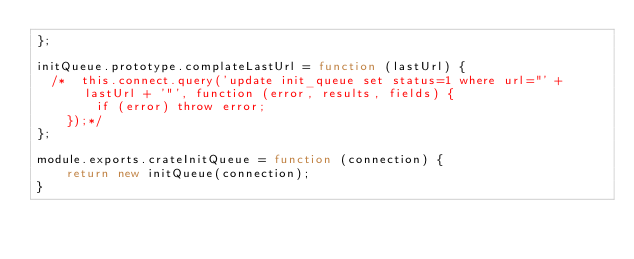Convert code to text. <code><loc_0><loc_0><loc_500><loc_500><_JavaScript_>};

initQueue.prototype.complateLastUrl = function (lastUrl) {
  /*  this.connect.query('update init_queue set status=1 where url="' + lastUrl + '"', function (error, results, fields) {
        if (error) throw error;
    });*/
};

module.exports.crateInitQueue = function (connection) {
    return new initQueue(connection);
}
</code> 